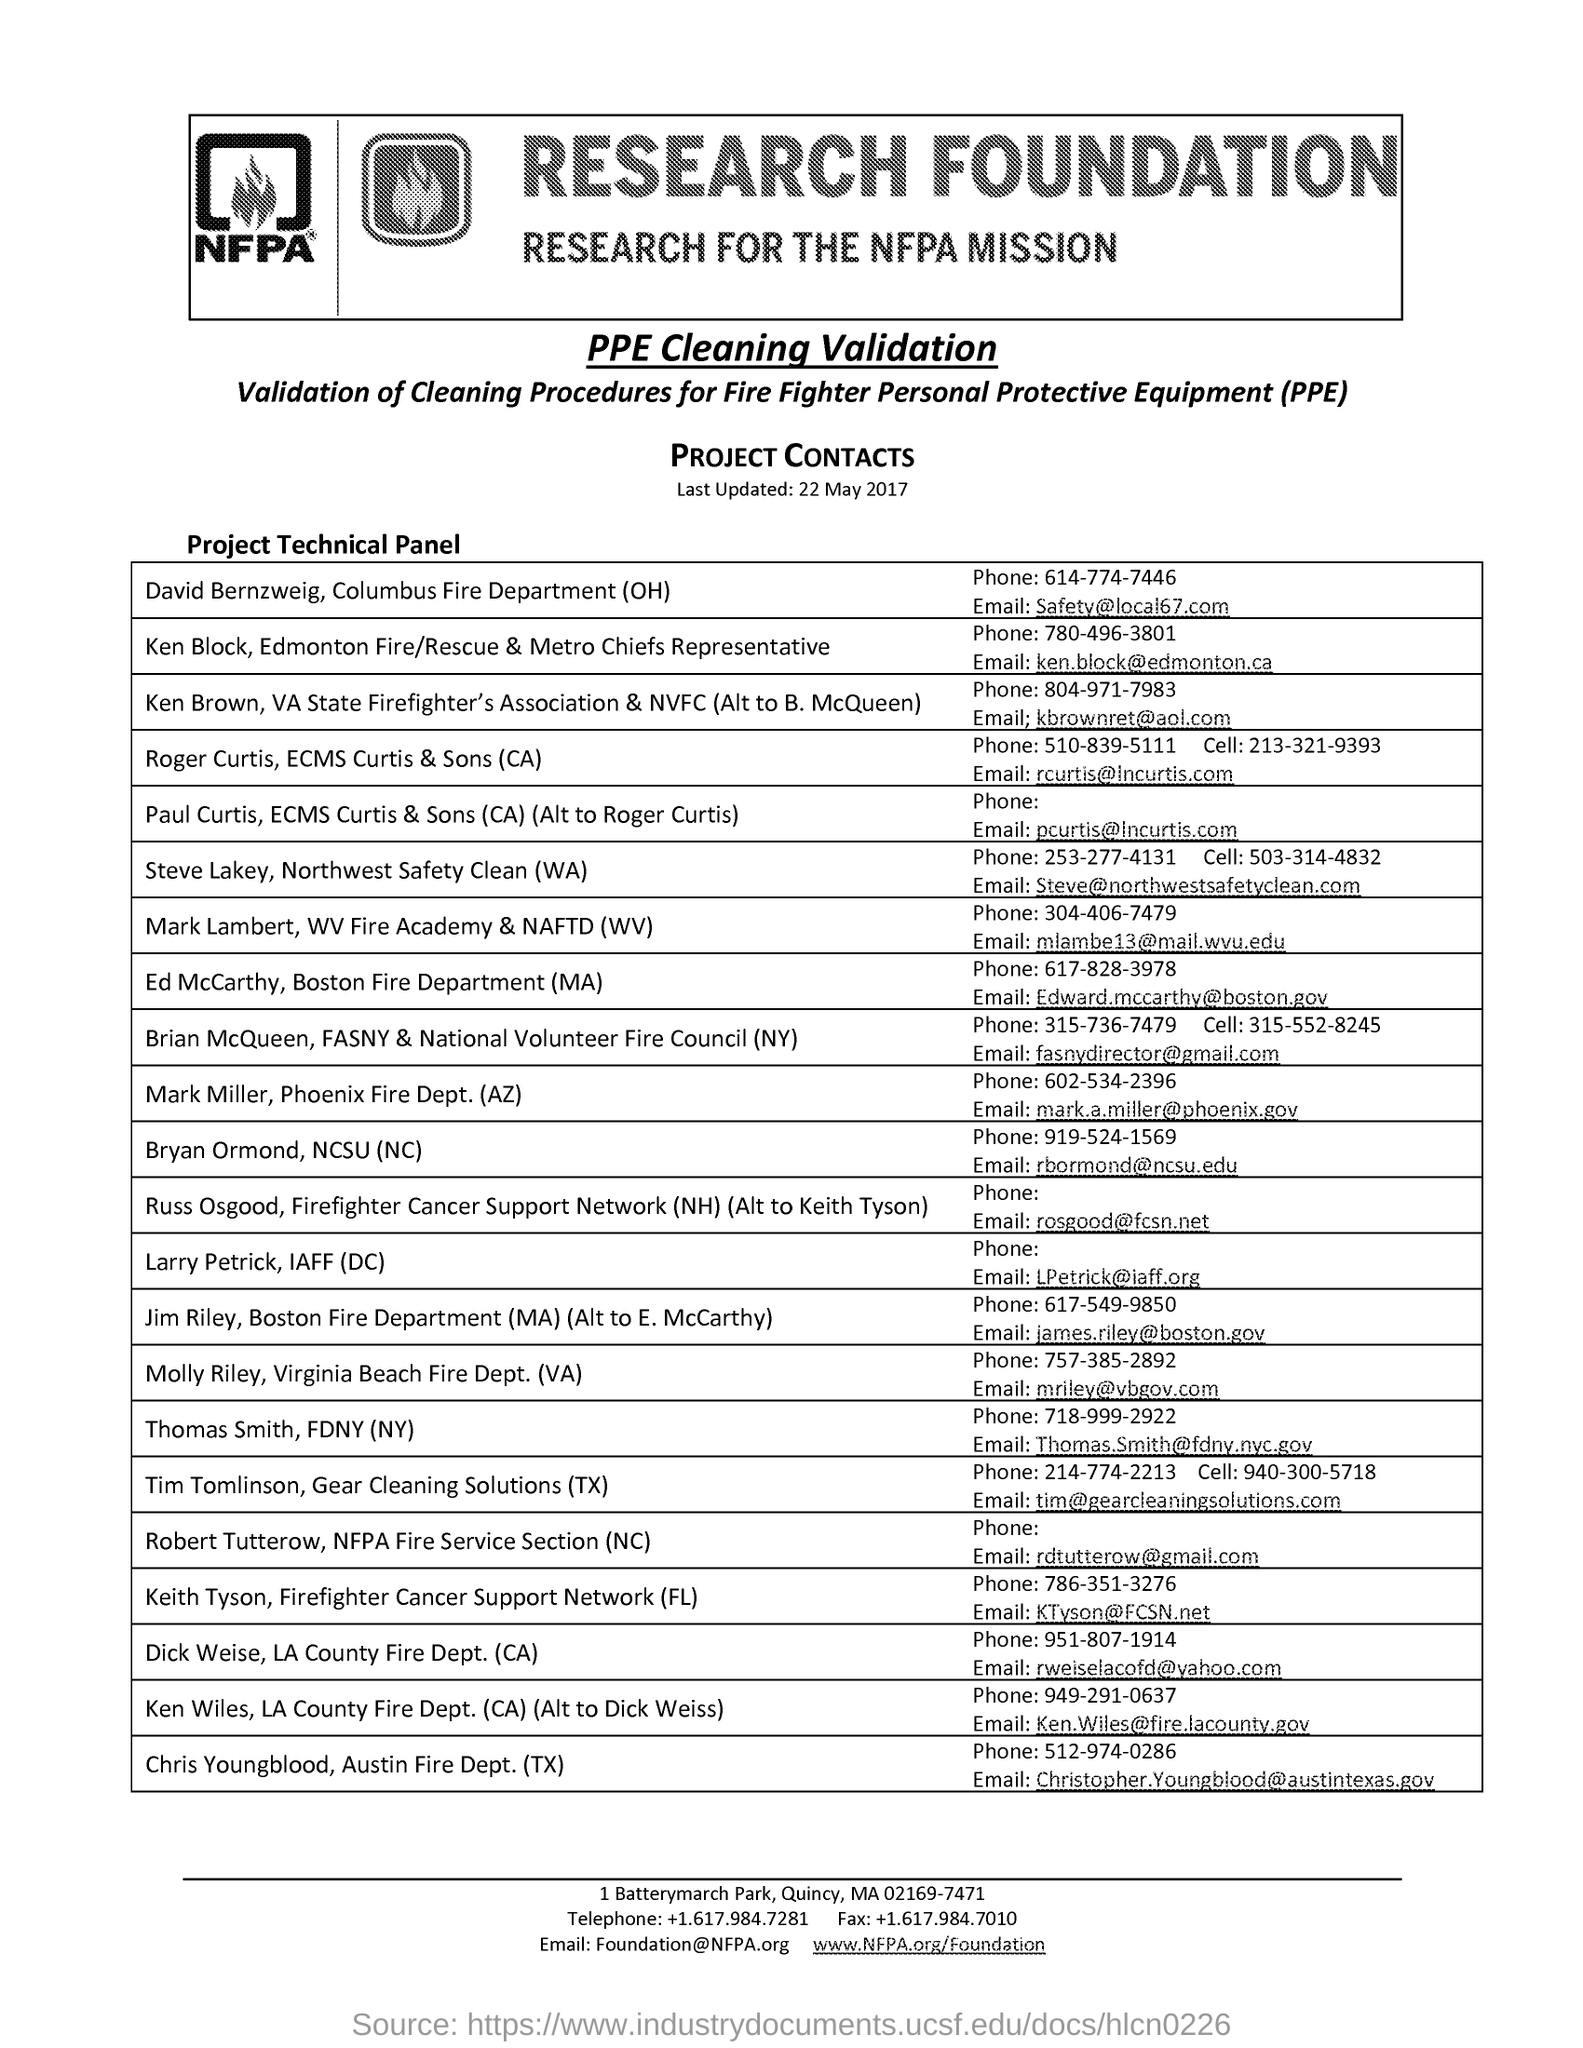What is the full form of ppe?
Ensure brevity in your answer.  Personal Protective Equipment. What is the subtitle for research foundation?
Provide a short and direct response. Research for the nfpa mission. What is the phone number for david bernzweig under the list of "project technical panel"?
Offer a very short reply. 614-774-7446. What is the email id for bryan ormand under the list of 'project technical panel'?
Offer a very short reply. Rbormond@ncsu.edu. 